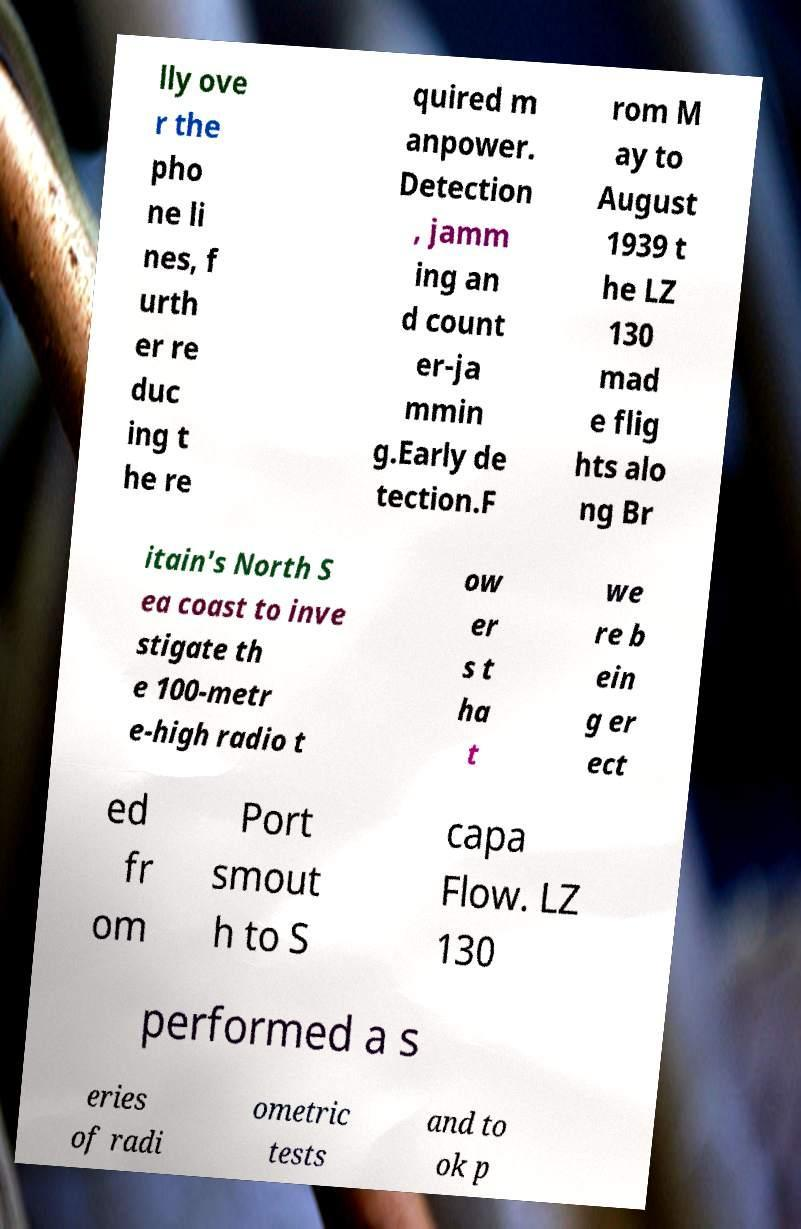There's text embedded in this image that I need extracted. Can you transcribe it verbatim? lly ove r the pho ne li nes, f urth er re duc ing t he re quired m anpower. Detection , jamm ing an d count er-ja mmin g.Early de tection.F rom M ay to August 1939 t he LZ 130 mad e flig hts alo ng Br itain's North S ea coast to inve stigate th e 100-metr e-high radio t ow er s t ha t we re b ein g er ect ed fr om Port smout h to S capa Flow. LZ 130 performed a s eries of radi ometric tests and to ok p 